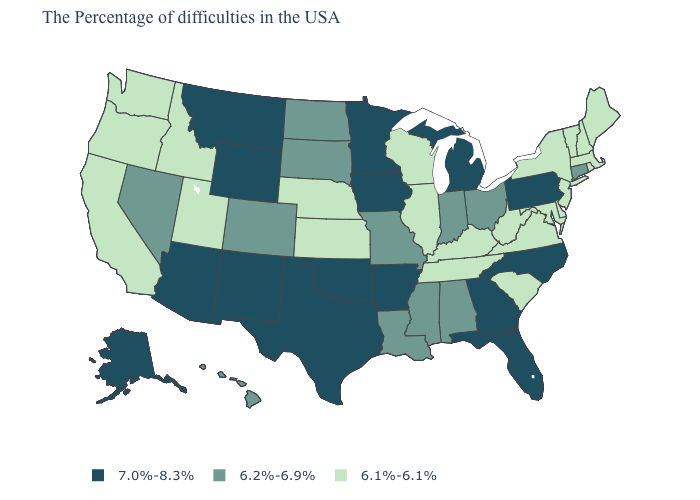What is the value of North Dakota?
Quick response, please. 6.2%-6.9%. Which states hav the highest value in the West?
Short answer required. Wyoming, New Mexico, Montana, Arizona, Alaska. Name the states that have a value in the range 7.0%-8.3%?
Short answer required. Pennsylvania, North Carolina, Florida, Georgia, Michigan, Arkansas, Minnesota, Iowa, Oklahoma, Texas, Wyoming, New Mexico, Montana, Arizona, Alaska. Which states have the lowest value in the USA?
Answer briefly. Maine, Massachusetts, Rhode Island, New Hampshire, Vermont, New York, New Jersey, Delaware, Maryland, Virginia, South Carolina, West Virginia, Kentucky, Tennessee, Wisconsin, Illinois, Kansas, Nebraska, Utah, Idaho, California, Washington, Oregon. Among the states that border Massachusetts , does Rhode Island have the highest value?
Keep it brief. No. Does the first symbol in the legend represent the smallest category?
Answer briefly. No. Name the states that have a value in the range 7.0%-8.3%?
Quick response, please. Pennsylvania, North Carolina, Florida, Georgia, Michigan, Arkansas, Minnesota, Iowa, Oklahoma, Texas, Wyoming, New Mexico, Montana, Arizona, Alaska. What is the value of New York?
Write a very short answer. 6.1%-6.1%. What is the value of Alaska?
Be succinct. 7.0%-8.3%. Which states have the highest value in the USA?
Keep it brief. Pennsylvania, North Carolina, Florida, Georgia, Michigan, Arkansas, Minnesota, Iowa, Oklahoma, Texas, Wyoming, New Mexico, Montana, Arizona, Alaska. Name the states that have a value in the range 6.1%-6.1%?
Concise answer only. Maine, Massachusetts, Rhode Island, New Hampshire, Vermont, New York, New Jersey, Delaware, Maryland, Virginia, South Carolina, West Virginia, Kentucky, Tennessee, Wisconsin, Illinois, Kansas, Nebraska, Utah, Idaho, California, Washington, Oregon. What is the value of Missouri?
Write a very short answer. 6.2%-6.9%. Which states hav the highest value in the MidWest?
Write a very short answer. Michigan, Minnesota, Iowa. Name the states that have a value in the range 6.1%-6.1%?
Give a very brief answer. Maine, Massachusetts, Rhode Island, New Hampshire, Vermont, New York, New Jersey, Delaware, Maryland, Virginia, South Carolina, West Virginia, Kentucky, Tennessee, Wisconsin, Illinois, Kansas, Nebraska, Utah, Idaho, California, Washington, Oregon. What is the lowest value in the USA?
Keep it brief. 6.1%-6.1%. 